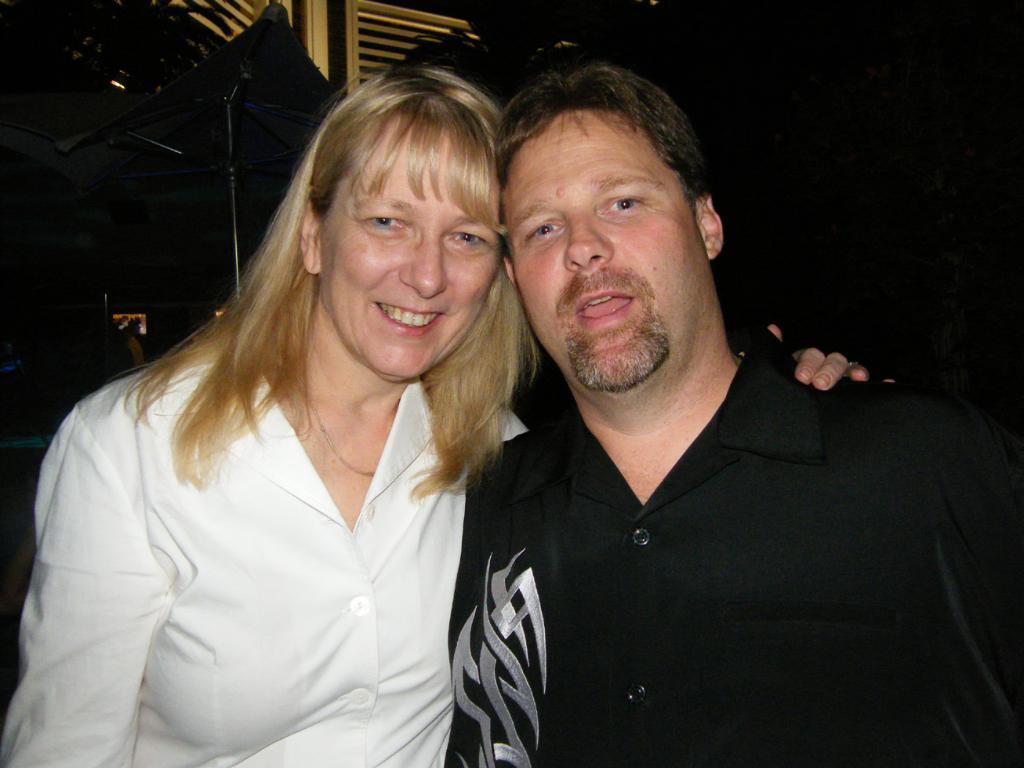In one or two sentences, can you explain what this image depicts? In the front of the image I can see a woman and man. In the background of the image it is dark. I can see an umbrella, stand and grilles.   